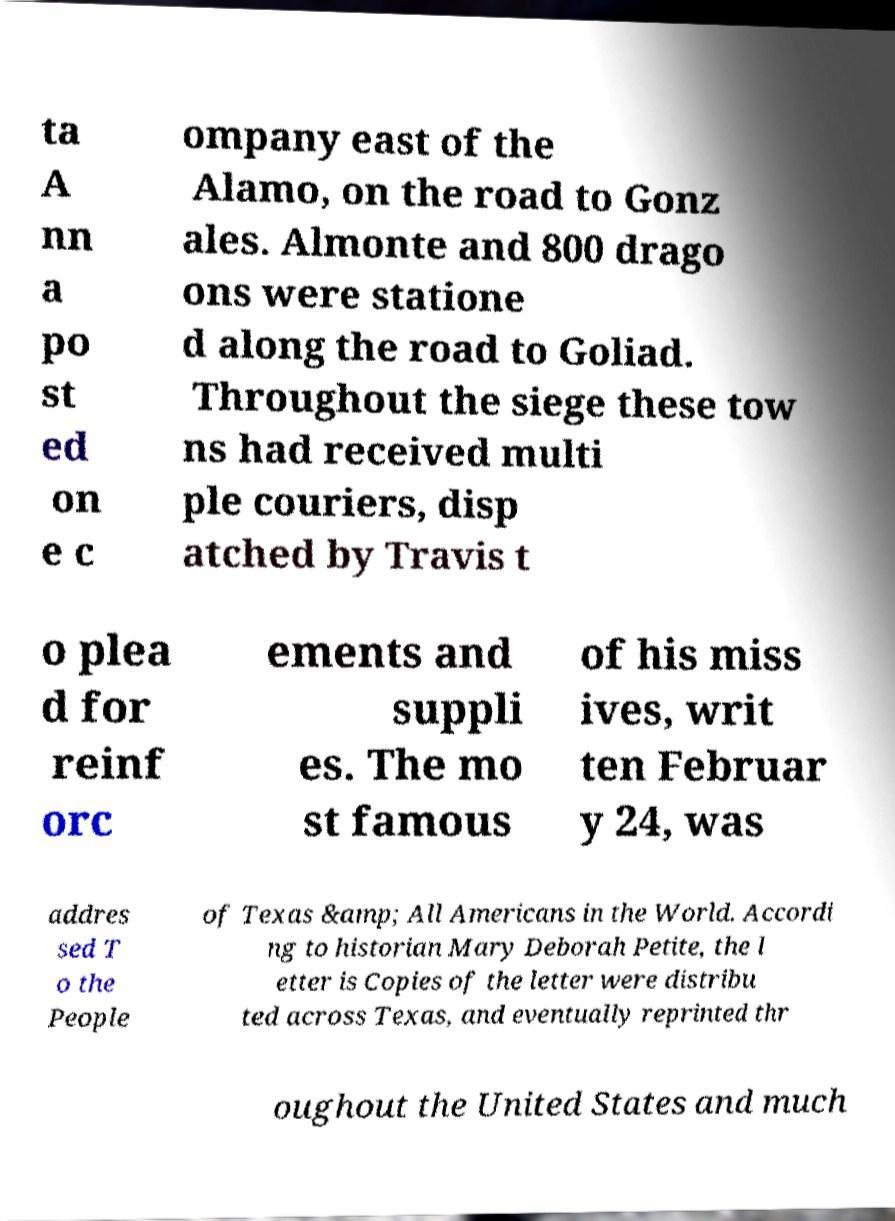There's text embedded in this image that I need extracted. Can you transcribe it verbatim? ta A nn a po st ed on e c ompany east of the Alamo, on the road to Gonz ales. Almonte and 800 drago ons were statione d along the road to Goliad. Throughout the siege these tow ns had received multi ple couriers, disp atched by Travis t o plea d for reinf orc ements and suppli es. The mo st famous of his miss ives, writ ten Februar y 24, was addres sed T o the People of Texas &amp; All Americans in the World. Accordi ng to historian Mary Deborah Petite, the l etter is Copies of the letter were distribu ted across Texas, and eventually reprinted thr oughout the United States and much 